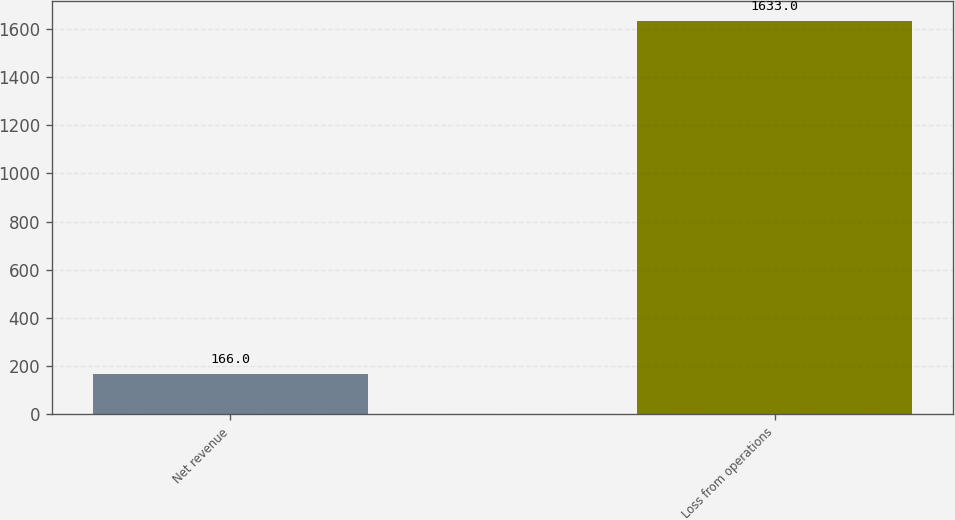<chart> <loc_0><loc_0><loc_500><loc_500><bar_chart><fcel>Net revenue<fcel>Loss from operations<nl><fcel>166<fcel>1633<nl></chart> 